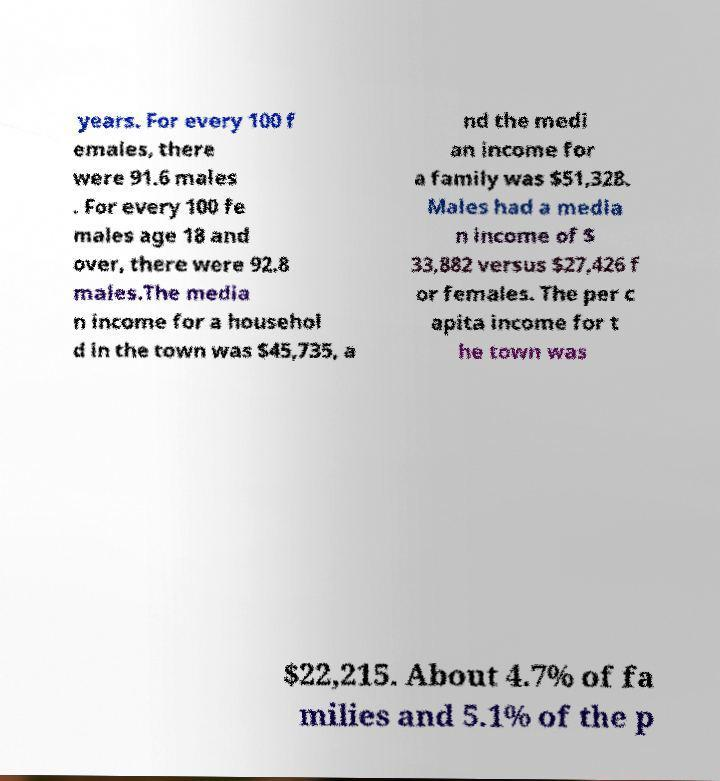There's text embedded in this image that I need extracted. Can you transcribe it verbatim? years. For every 100 f emales, there were 91.6 males . For every 100 fe males age 18 and over, there were 92.8 males.The media n income for a househol d in the town was $45,735, a nd the medi an income for a family was $51,328. Males had a media n income of $ 33,882 versus $27,426 f or females. The per c apita income for t he town was $22,215. About 4.7% of fa milies and 5.1% of the p 